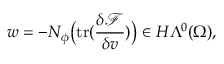<formula> <loc_0><loc_0><loc_500><loc_500>w = - N _ { \phi } \left ( t r ( \frac { \delta \mathcal { F } } { \delta v } ) \right ) \in H \Lambda ^ { 0 } ( \Omega ) ,</formula> 